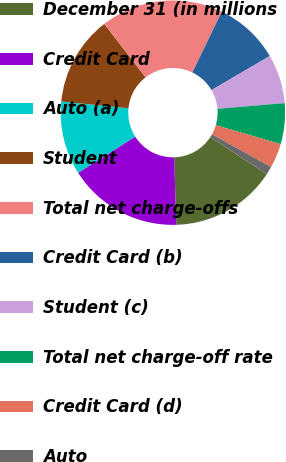<chart> <loc_0><loc_0><loc_500><loc_500><pie_chart><fcel>December 31 (in millions<fcel>Credit Card<fcel>Auto (a)<fcel>Student<fcel>Total net charge-offs<fcel>Credit Card (b)<fcel>Student (c)<fcel>Total net charge-off rate<fcel>Credit Card (d)<fcel>Auto<nl><fcel>15.29%<fcel>16.47%<fcel>10.59%<fcel>12.94%<fcel>17.65%<fcel>9.41%<fcel>7.06%<fcel>5.88%<fcel>3.53%<fcel>1.18%<nl></chart> 